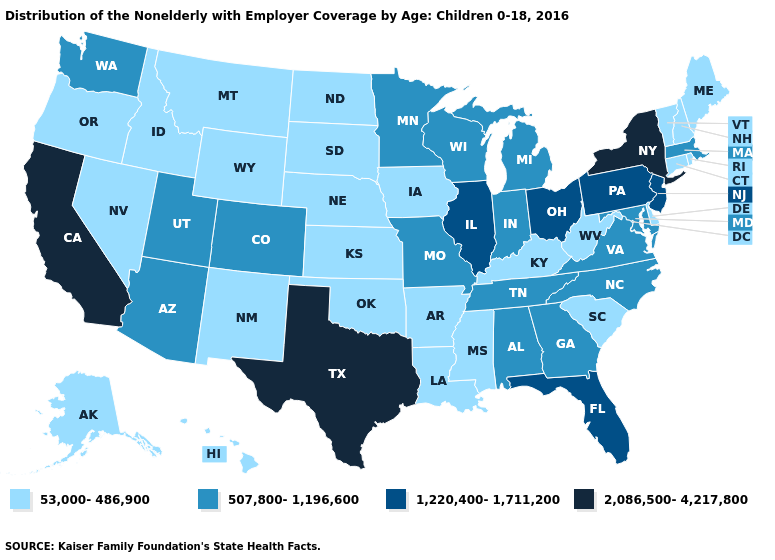Which states have the lowest value in the Northeast?
Keep it brief. Connecticut, Maine, New Hampshire, Rhode Island, Vermont. Name the states that have a value in the range 53,000-486,900?
Keep it brief. Alaska, Arkansas, Connecticut, Delaware, Hawaii, Idaho, Iowa, Kansas, Kentucky, Louisiana, Maine, Mississippi, Montana, Nebraska, Nevada, New Hampshire, New Mexico, North Dakota, Oklahoma, Oregon, Rhode Island, South Carolina, South Dakota, Vermont, West Virginia, Wyoming. What is the lowest value in the Northeast?
Quick response, please. 53,000-486,900. Name the states that have a value in the range 53,000-486,900?
Be succinct. Alaska, Arkansas, Connecticut, Delaware, Hawaii, Idaho, Iowa, Kansas, Kentucky, Louisiana, Maine, Mississippi, Montana, Nebraska, Nevada, New Hampshire, New Mexico, North Dakota, Oklahoma, Oregon, Rhode Island, South Carolina, South Dakota, Vermont, West Virginia, Wyoming. Name the states that have a value in the range 507,800-1,196,600?
Keep it brief. Alabama, Arizona, Colorado, Georgia, Indiana, Maryland, Massachusetts, Michigan, Minnesota, Missouri, North Carolina, Tennessee, Utah, Virginia, Washington, Wisconsin. What is the value of Virginia?
Keep it brief. 507,800-1,196,600. Among the states that border Connecticut , does Rhode Island have the highest value?
Quick response, please. No. What is the value of North Carolina?
Be succinct. 507,800-1,196,600. Does Wyoming have the lowest value in the West?
Answer briefly. Yes. Among the states that border Utah , which have the highest value?
Short answer required. Arizona, Colorado. What is the value of Ohio?
Be succinct. 1,220,400-1,711,200. Does the map have missing data?
Concise answer only. No. What is the highest value in the USA?
Be succinct. 2,086,500-4,217,800. What is the value of South Dakota?
Concise answer only. 53,000-486,900. What is the value of Massachusetts?
Quick response, please. 507,800-1,196,600. 